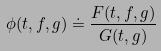Convert formula to latex. <formula><loc_0><loc_0><loc_500><loc_500>\phi ( t , f , g ) \doteq \frac { F ( t , f , g ) } { G ( t , g ) }</formula> 